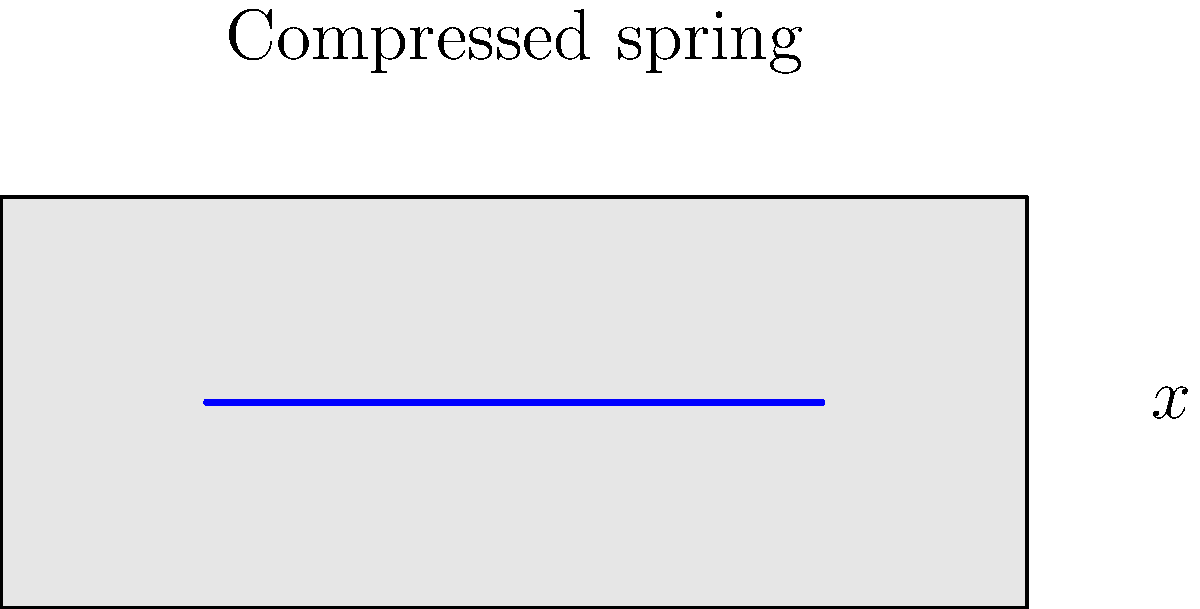A mattress spring is compressed by 0.2 meters from its equilibrium position. If the spring constant is 2000 N/m, calculate the potential energy stored in the spring. How might this energy relate to the comfort and support provided by the mattress in a marital bed? Let's approach this step-by-step:

1) The formula for potential energy in a spring is:
   $$U = \frac{1}{2}kx^2$$
   Where:
   $U$ = potential energy
   $k$ = spring constant
   $x$ = displacement from equilibrium

2) We are given:
   $k = 2000$ N/m
   $x = 0.2$ m

3) Let's substitute these values into our equation:
   $$U = \frac{1}{2} \cdot 2000 \cdot (0.2)^2$$

4) Calculate:
   $$U = 1000 \cdot 0.04 = 40\text{ J}$$

5) Regarding the comfort and support in a marital bed:
   - The stored energy represents the mattress's ability to push back and support body weight.
   - A higher energy storage capacity could mean better support, potentially reducing partner disturbance during sleep.
   - However, the ideal energy storage depends on individual preferences for mattress firmness, which could be a point of discussion in marital therapy or separation considerations.
Answer: 40 J 